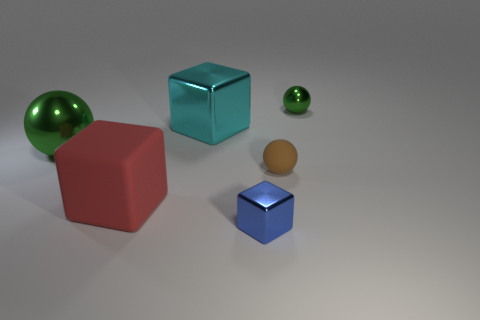Subtract all big blocks. How many blocks are left? 1 Add 4 big green balls. How many objects exist? 10 Subtract 1 blocks. How many blocks are left? 2 Subtract all green spheres. How many spheres are left? 1 Subtract all blue cubes. How many green spheres are left? 2 Add 1 brown shiny things. How many brown shiny things exist? 1 Subtract 1 brown spheres. How many objects are left? 5 Subtract all purple balls. Subtract all green cubes. How many balls are left? 3 Subtract all big brown matte cubes. Subtract all tiny balls. How many objects are left? 4 Add 3 big green shiny things. How many big green shiny things are left? 4 